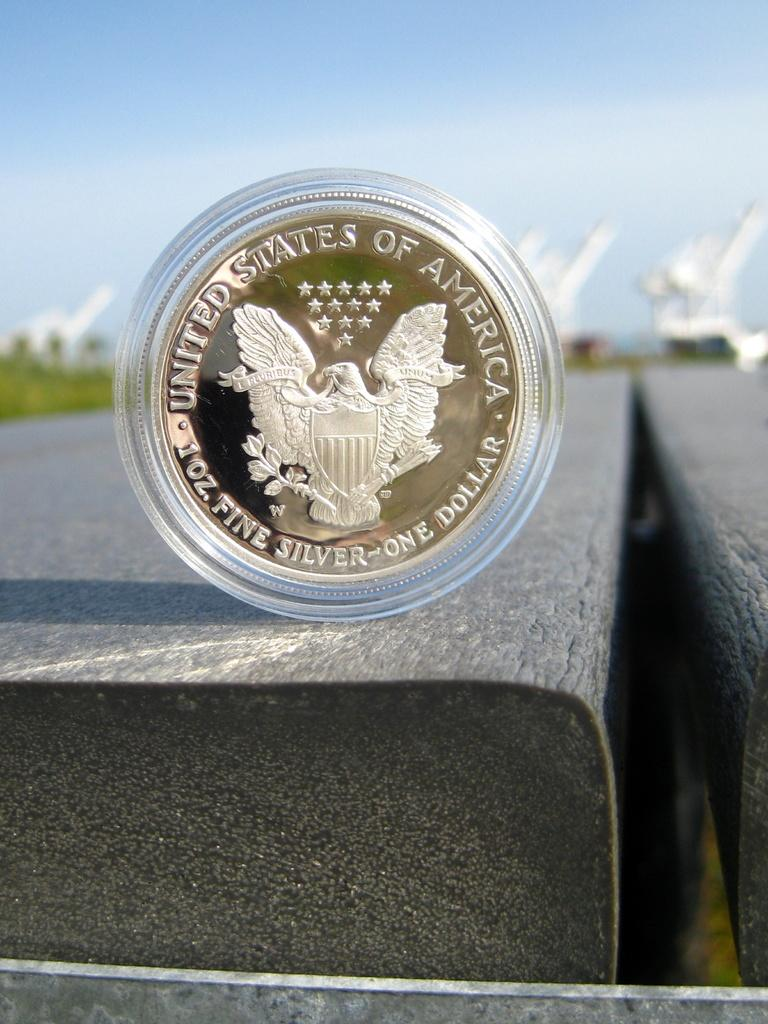<image>
Describe the image concisely. A United States silver dollar stands upright on a wood plank. 